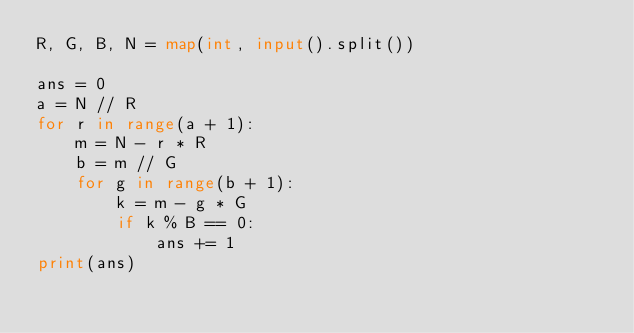<code> <loc_0><loc_0><loc_500><loc_500><_Python_>R, G, B, N = map(int, input().split())

ans = 0
a = N // R
for r in range(a + 1):
    m = N - r * R
    b = m // G
    for g in range(b + 1):
        k = m - g * G
        if k % B == 0:
            ans += 1
print(ans)</code> 